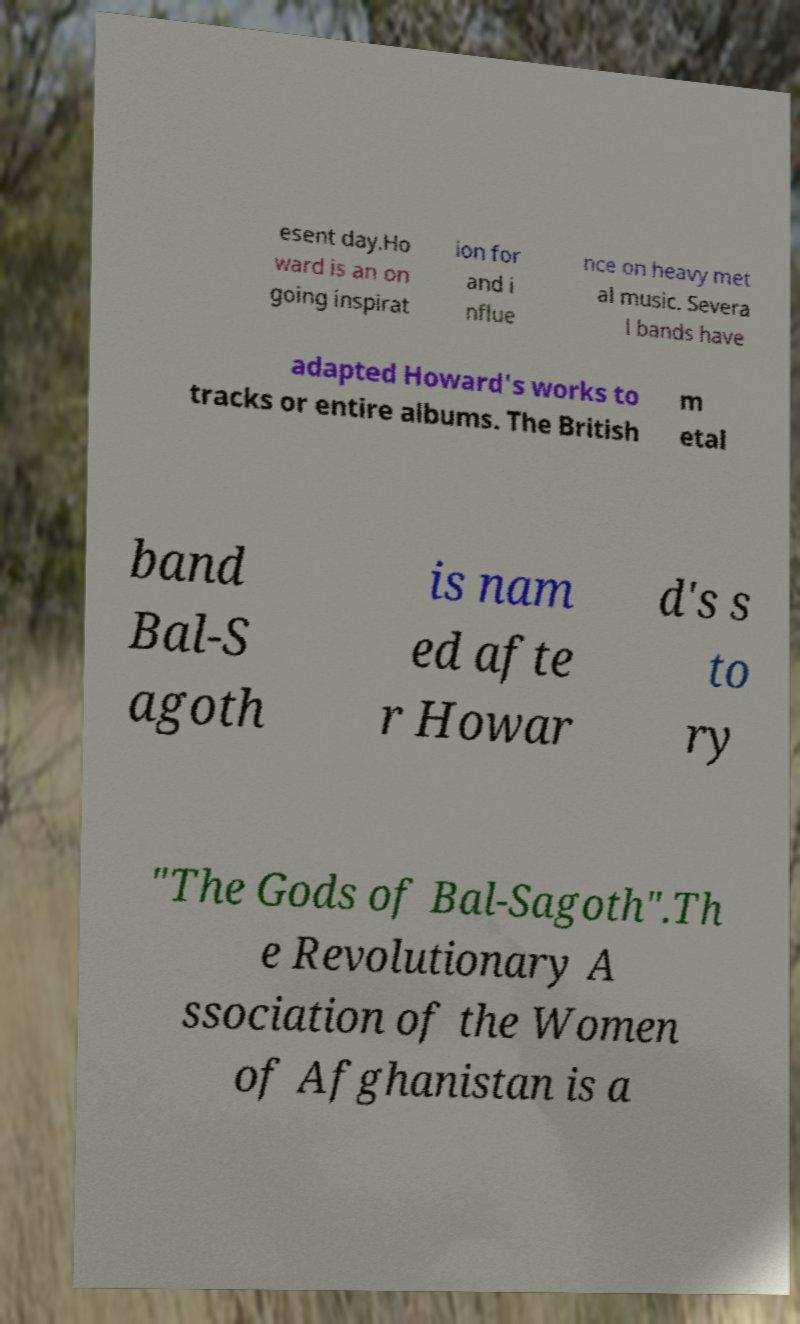Could you assist in decoding the text presented in this image and type it out clearly? esent day.Ho ward is an on going inspirat ion for and i nflue nce on heavy met al music. Severa l bands have adapted Howard's works to tracks or entire albums. The British m etal band Bal-S agoth is nam ed afte r Howar d's s to ry "The Gods of Bal-Sagoth".Th e Revolutionary A ssociation of the Women of Afghanistan is a 